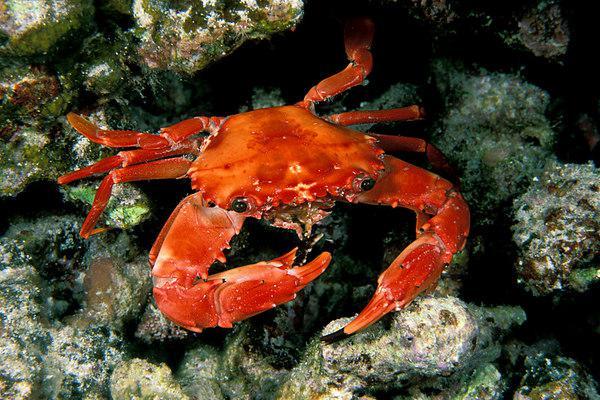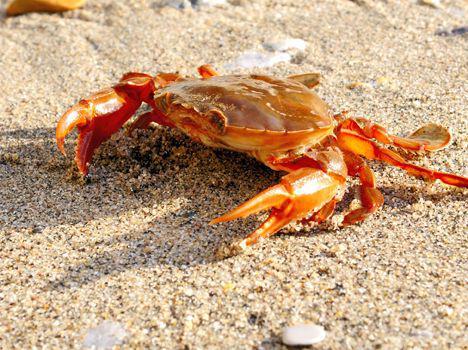The first image is the image on the left, the second image is the image on the right. For the images shown, is this caption "Each image shows a crab with its face toward the front instead of rear-facing, and all crabs are angled leftward." true? Answer yes or no. No. 